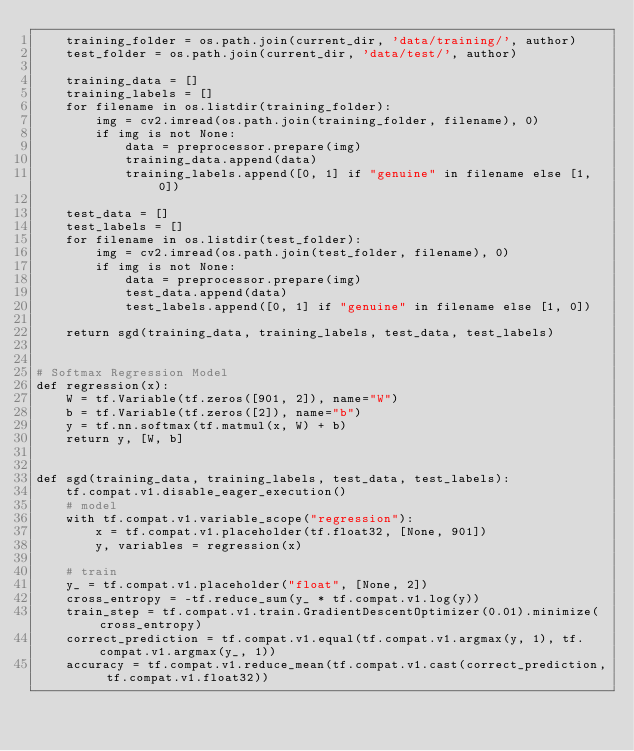Convert code to text. <code><loc_0><loc_0><loc_500><loc_500><_Python_>    training_folder = os.path.join(current_dir, 'data/training/', author)
    test_folder = os.path.join(current_dir, 'data/test/', author)

    training_data = []
    training_labels = []
    for filename in os.listdir(training_folder):
        img = cv2.imread(os.path.join(training_folder, filename), 0)
        if img is not None:
            data = preprocessor.prepare(img)
            training_data.append(data)
            training_labels.append([0, 1] if "genuine" in filename else [1, 0])

    test_data = []
    test_labels = []
    for filename in os.listdir(test_folder):
        img = cv2.imread(os.path.join(test_folder, filename), 0)
        if img is not None:
            data = preprocessor.prepare(img)
            test_data.append(data)
            test_labels.append([0, 1] if "genuine" in filename else [1, 0])

    return sgd(training_data, training_labels, test_data, test_labels)


# Softmax Regression Model
def regression(x):
    W = tf.Variable(tf.zeros([901, 2]), name="W")
    b = tf.Variable(tf.zeros([2]), name="b")
    y = tf.nn.softmax(tf.matmul(x, W) + b)
    return y, [W, b]


def sgd(training_data, training_labels, test_data, test_labels):
    tf.compat.v1.disable_eager_execution()
    # model
    with tf.compat.v1.variable_scope("regression"):
        x = tf.compat.v1.placeholder(tf.float32, [None, 901])
        y, variables = regression(x)

    # train
    y_ = tf.compat.v1.placeholder("float", [None, 2])
    cross_entropy = -tf.reduce_sum(y_ * tf.compat.v1.log(y))
    train_step = tf.compat.v1.train.GradientDescentOptimizer(0.01).minimize(cross_entropy)
    correct_prediction = tf.compat.v1.equal(tf.compat.v1.argmax(y, 1), tf.compat.v1.argmax(y_, 1))
    accuracy = tf.compat.v1.reduce_mean(tf.compat.v1.cast(correct_prediction, tf.compat.v1.float32))
</code> 